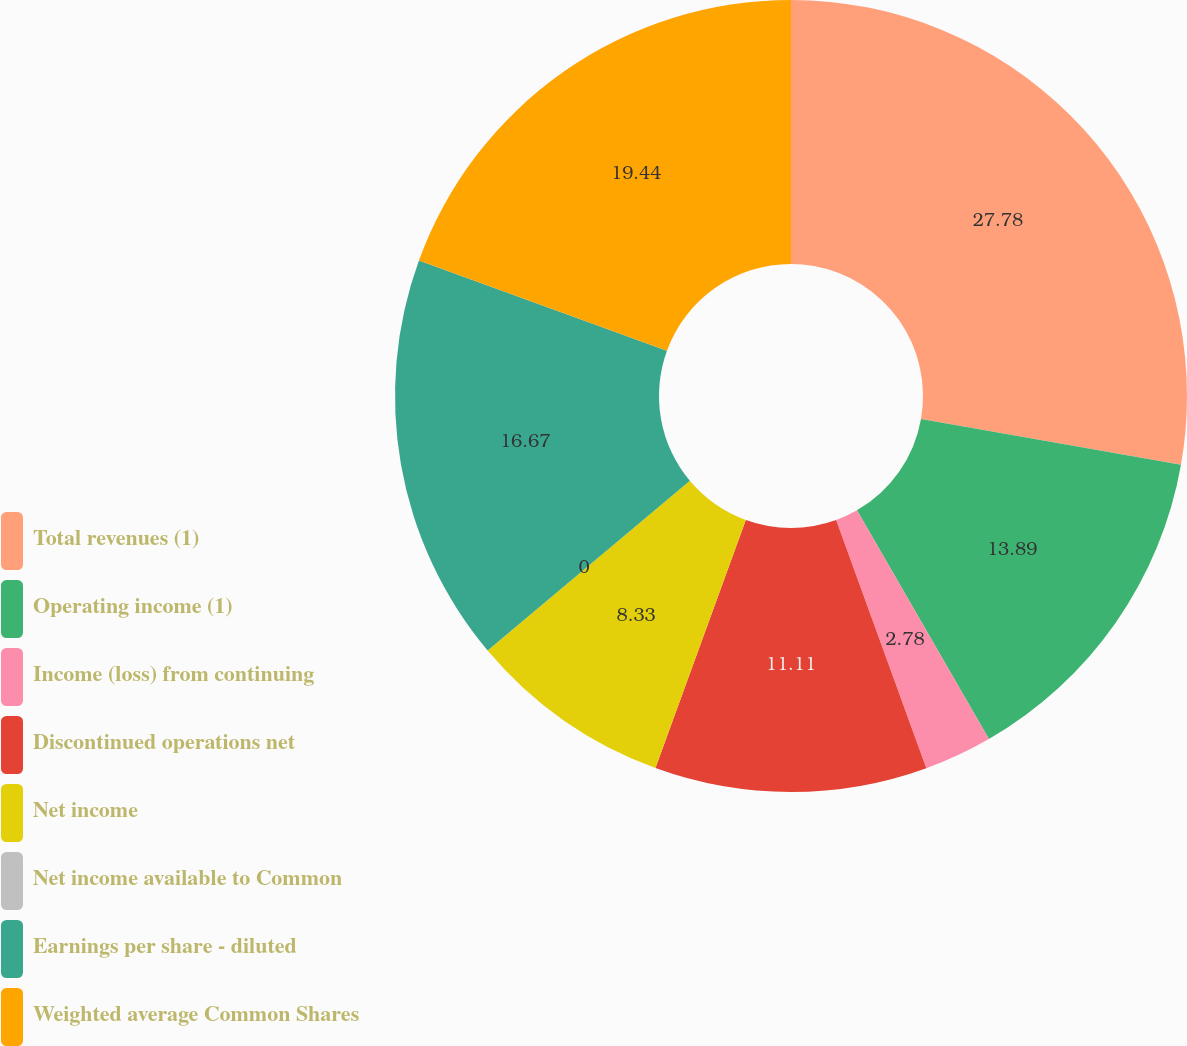<chart> <loc_0><loc_0><loc_500><loc_500><pie_chart><fcel>Total revenues (1)<fcel>Operating income (1)<fcel>Income (loss) from continuing<fcel>Discontinued operations net<fcel>Net income<fcel>Net income available to Common<fcel>Earnings per share - diluted<fcel>Weighted average Common Shares<nl><fcel>27.78%<fcel>13.89%<fcel>2.78%<fcel>11.11%<fcel>8.33%<fcel>0.0%<fcel>16.67%<fcel>19.44%<nl></chart> 